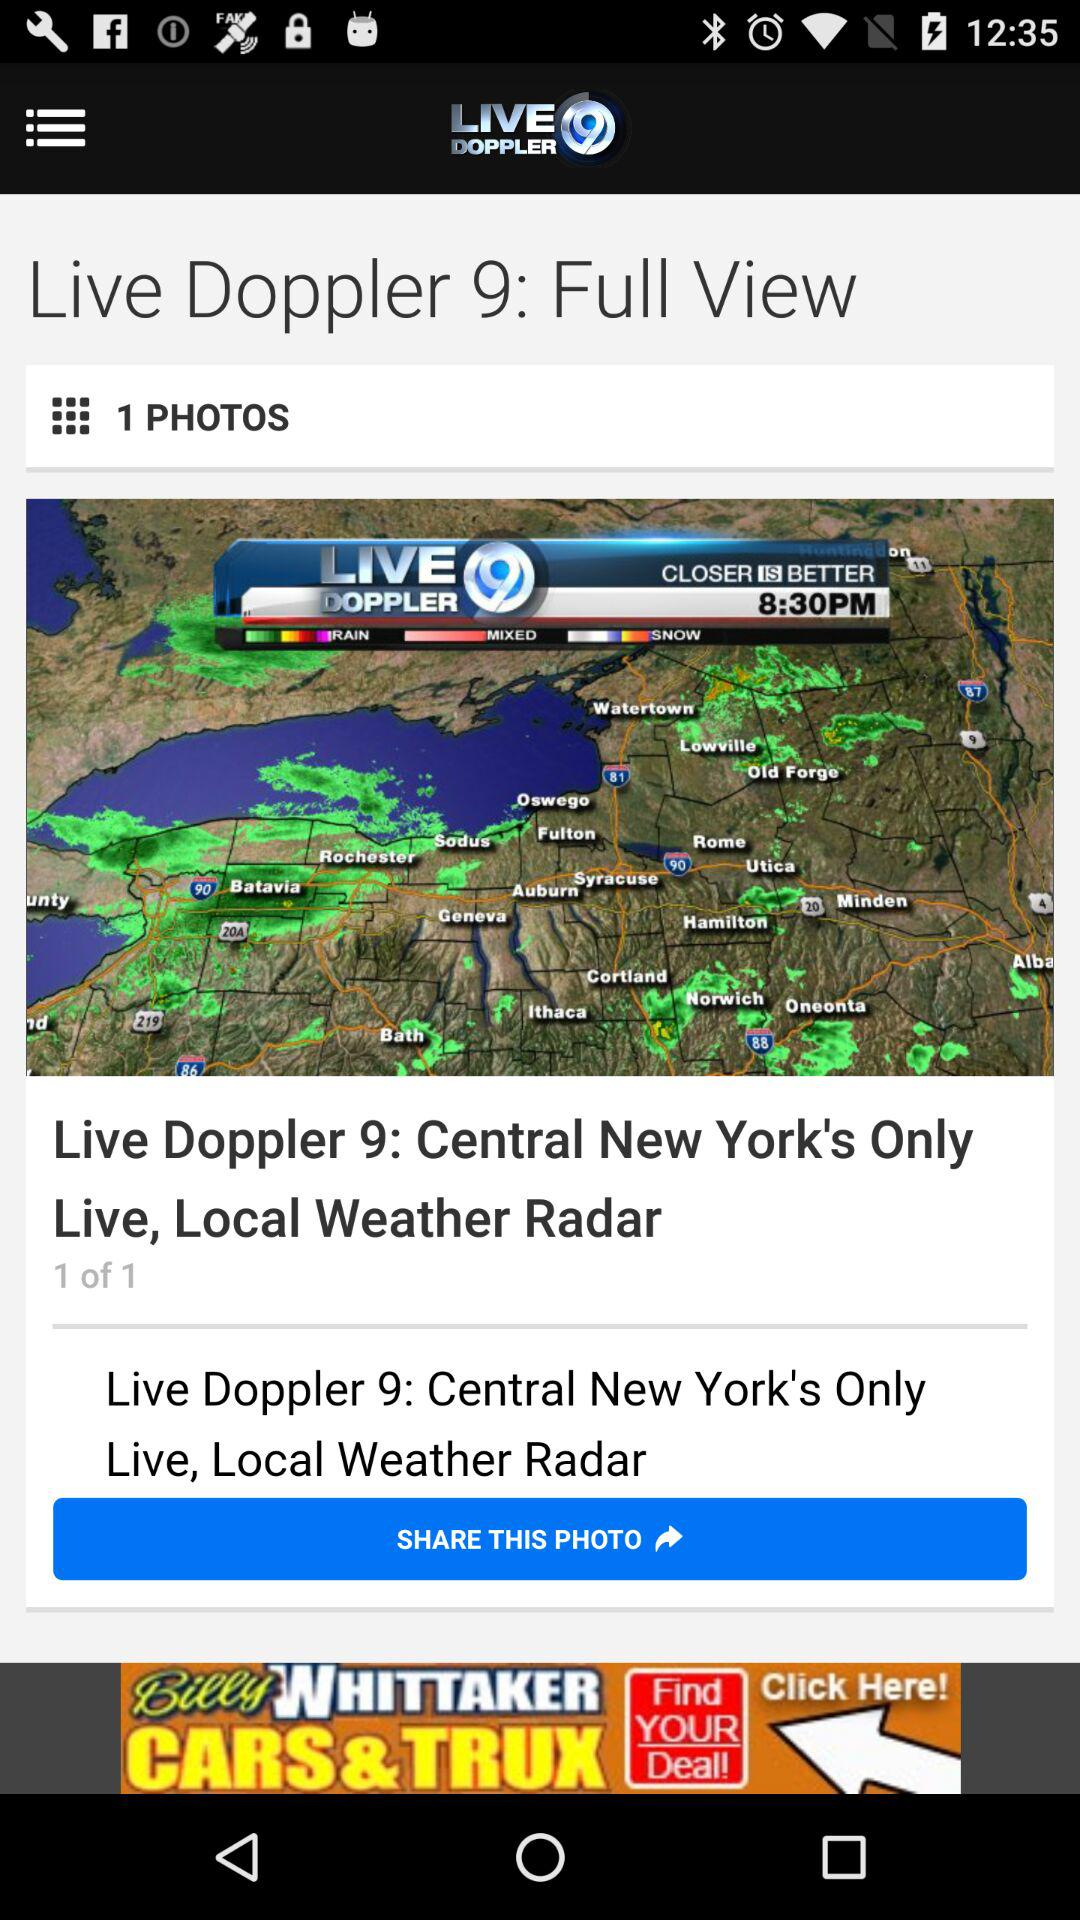How many photos are on the screen?
Answer the question using a single word or phrase. 1 